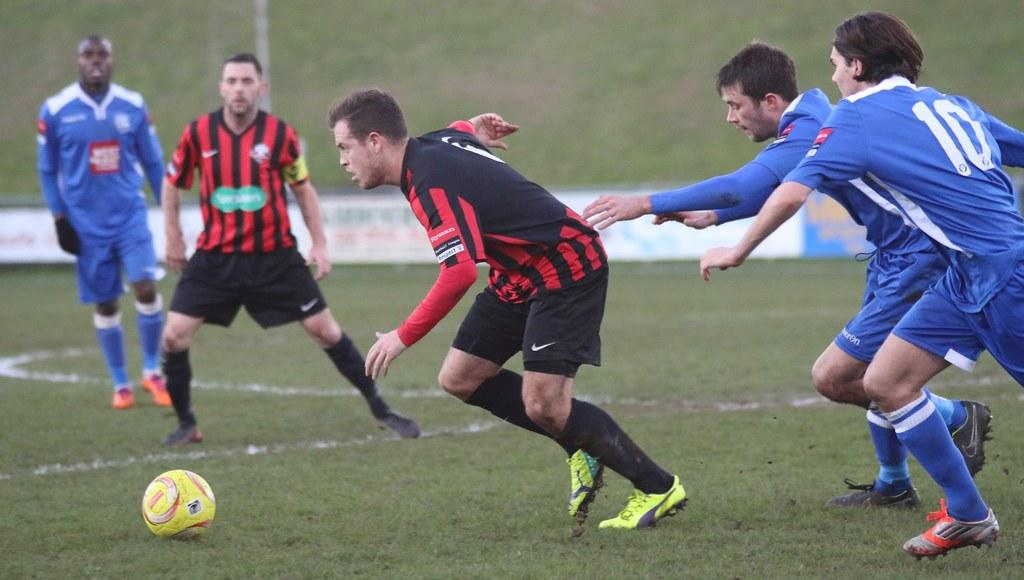What activity are the people in the image engaged in? The people in the image are playing soccer. What type of surface is the soccer game being played on? The soccer game is being played on a grassy ground. Are there any additional features visible in the image? Yes, there are advertising boards in the image. What type of teeth can be seen on the soccer ball in the image? There are no teeth visible on the soccer ball in the image, as soccer balls do not have teeth. 